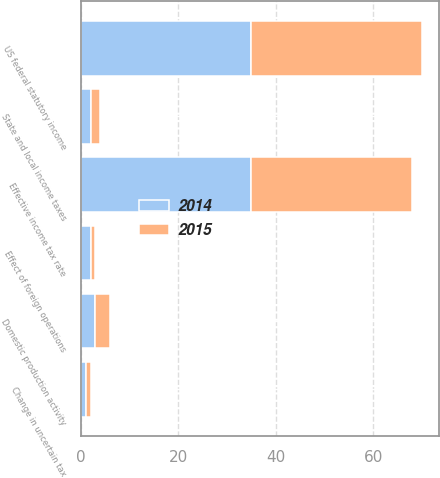Convert chart to OTSL. <chart><loc_0><loc_0><loc_500><loc_500><stacked_bar_chart><ecel><fcel>US federal statutory income<fcel>State and local income taxes<fcel>Effect of foreign operations<fcel>Domestic production activity<fcel>Change in uncertain tax<fcel>Effective income tax rate<nl><fcel>2015<fcel>35<fcel>2<fcel>1<fcel>3<fcel>1<fcel>33<nl><fcel>2014<fcel>35<fcel>2<fcel>2<fcel>3<fcel>1<fcel>35<nl></chart> 